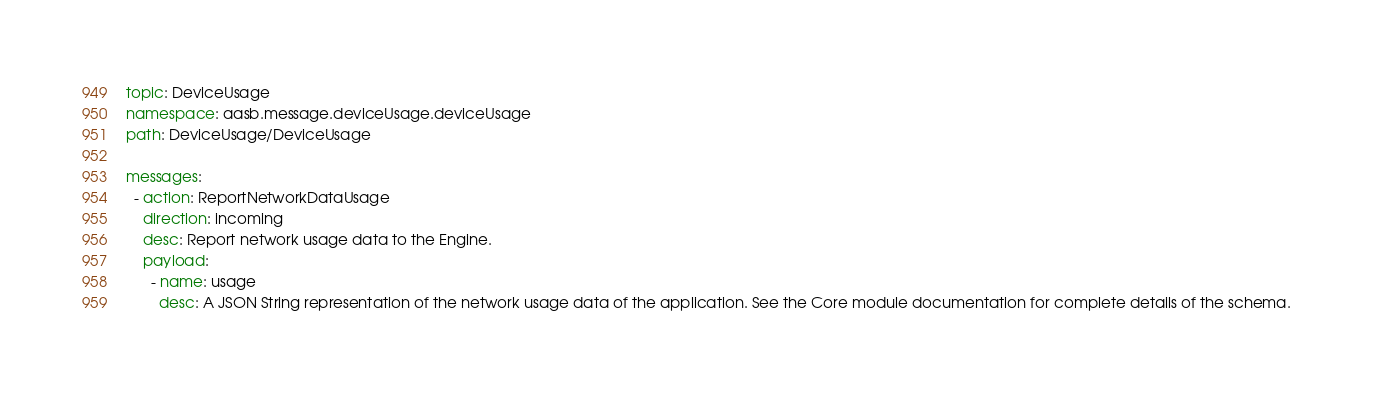Convert code to text. <code><loc_0><loc_0><loc_500><loc_500><_YAML_>topic: DeviceUsage
namespace: aasb.message.deviceUsage.deviceUsage
path: DeviceUsage/DeviceUsage

messages:
  - action: ReportNetworkDataUsage
    direction: incoming
    desc: Report network usage data to the Engine.
    payload:
      - name: usage
        desc: A JSON String representation of the network usage data of the application. See the Core module documentation for complete details of the schema. 

</code> 